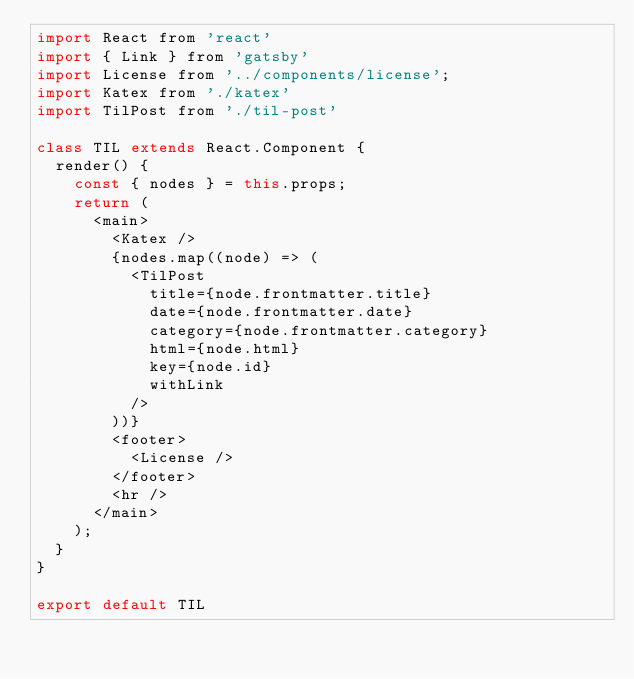Convert code to text. <code><loc_0><loc_0><loc_500><loc_500><_JavaScript_>import React from 'react'
import { Link } from 'gatsby'
import License from '../components/license';
import Katex from './katex'
import TilPost from './til-post'

class TIL extends React.Component {
  render() {
    const { nodes } = this.props;
    return (
      <main>
        <Katex />
        {nodes.map((node) => (
          <TilPost
            title={node.frontmatter.title}
            date={node.frontmatter.date}
            category={node.frontmatter.category}
            html={node.html}
            key={node.id}
            withLink
          />
        ))}
        <footer>
          <License />
        </footer>
        <hr />
      </main>
    );
  }
}

export default TIL
</code> 